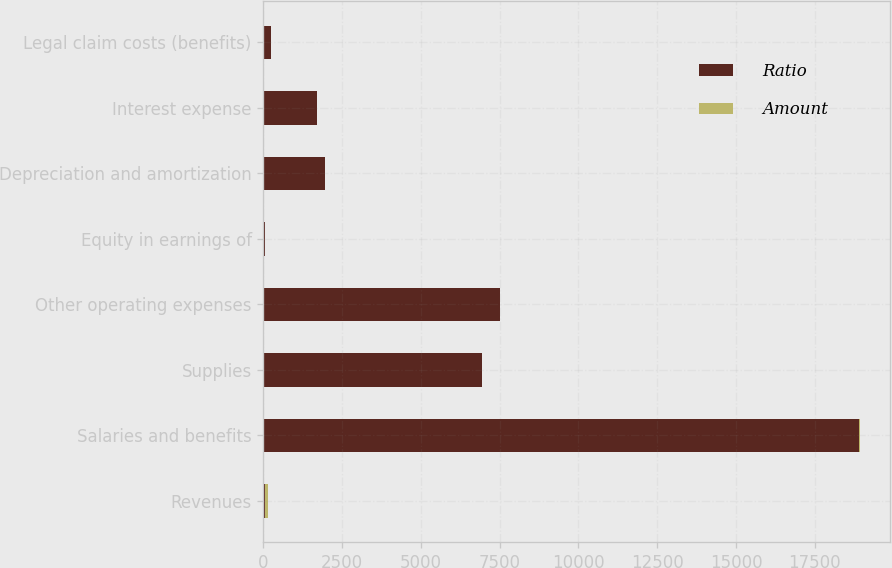<chart> <loc_0><loc_0><loc_500><loc_500><stacked_bar_chart><ecel><fcel>Revenues<fcel>Salaries and benefits<fcel>Supplies<fcel>Other operating expenses<fcel>Equity in earnings of<fcel>Depreciation and amortization<fcel>Interest expense<fcel>Legal claim costs (benefits)<nl><fcel>Ratio<fcel>54<fcel>18897<fcel>6933<fcel>7508<fcel>54<fcel>1966<fcel>1707<fcel>246<nl><fcel>Amount<fcel>100<fcel>45.5<fcel>16.7<fcel>18.1<fcel>0.1<fcel>4.8<fcel>4.1<fcel>0.6<nl></chart> 